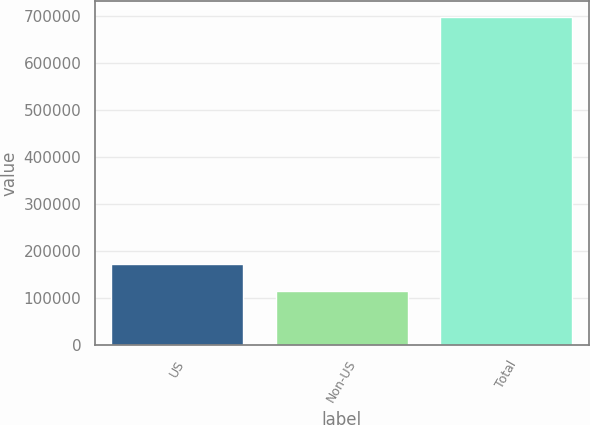Convert chart to OTSL. <chart><loc_0><loc_0><loc_500><loc_500><bar_chart><fcel>US<fcel>Non-US<fcel>Total<nl><fcel>172871<fcel>114445<fcel>698704<nl></chart> 